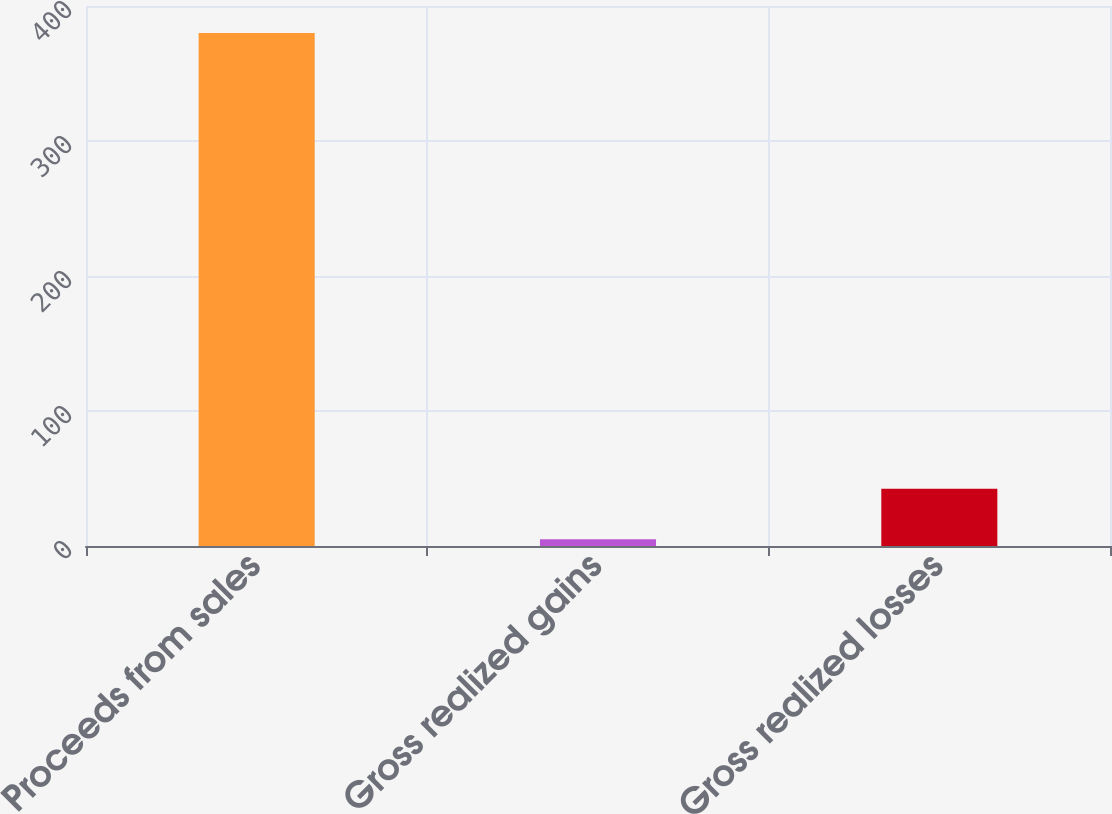Convert chart. <chart><loc_0><loc_0><loc_500><loc_500><bar_chart><fcel>Proceeds from sales<fcel>Gross realized gains<fcel>Gross realized losses<nl><fcel>380<fcel>5<fcel>42.5<nl></chart> 